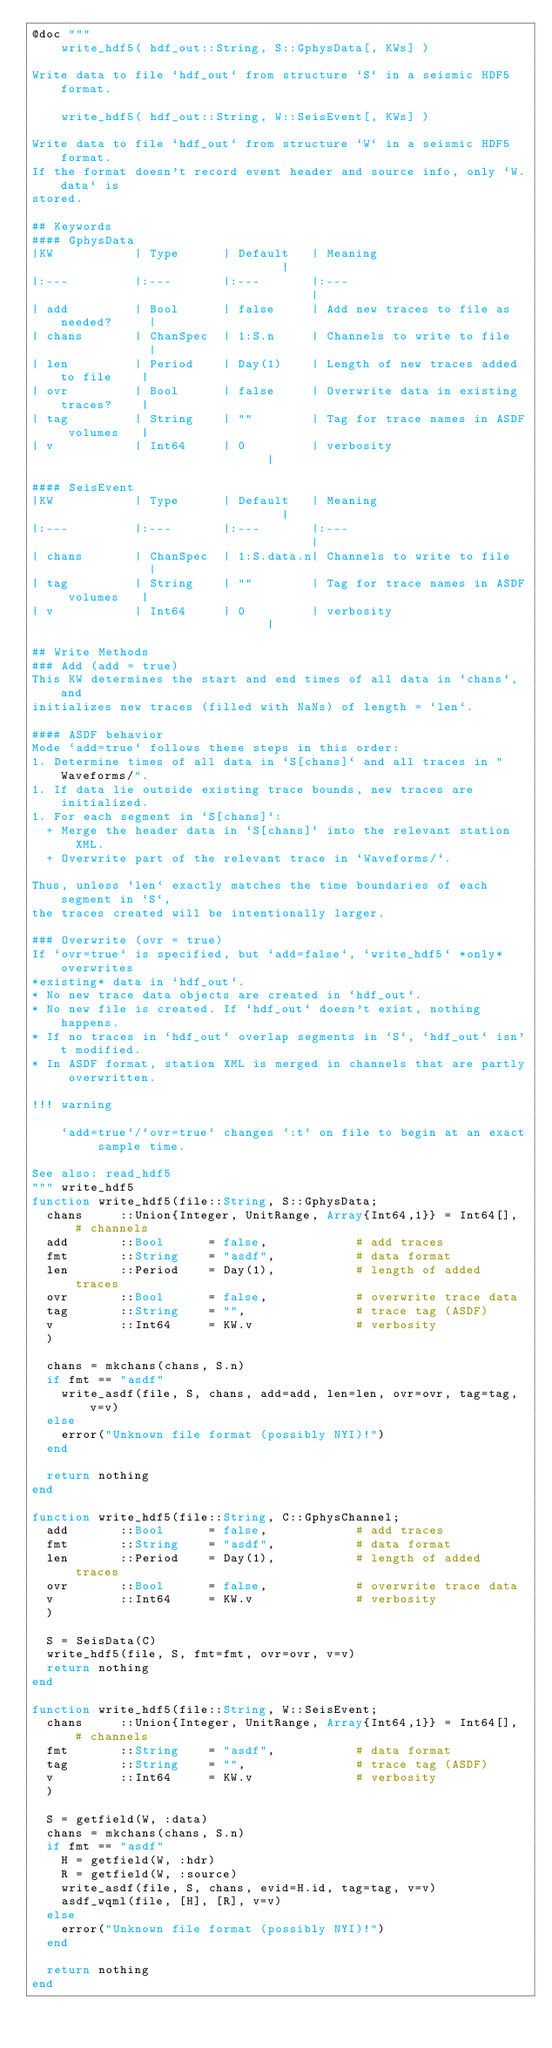Convert code to text. <code><loc_0><loc_0><loc_500><loc_500><_Julia_>@doc """
    write_hdf5( hdf_out::String, S::GphysData[, KWs] )

Write data to file `hdf_out` from structure `S` in a seismic HDF5 format.

    write_hdf5( hdf_out::String, W::SeisEvent[, KWs] )

Write data to file `hdf_out` from structure `W` in a seismic HDF5 format.
If the format doesn't record event header and source info, only `W.data` is
stored.

## Keywords
#### GphysData
|KW           | Type      | Default   | Meaning                               |
|:---         |:---       |:---       |:---                                   |
| add         | Bool      | false     | Add new traces to file as needed?     |
| chans       | ChanSpec  | 1:S.n     | Channels to write to file             |
| len         | Period    | Day(1)    | Length of new traces added to file    |
| ovr         | Bool      | false     | Overwrite data in existing traces?    |
| tag         | String    | ""        | Tag for trace names in ASDF volumes   |
| v           | Int64     | 0         | verbosity                             |

#### SeisEvent
|KW           | Type      | Default   | Meaning                               |
|:---         |:---       |:---       |:---                                   |
| chans       | ChanSpec  | 1:S.data.n| Channels to write to file             |
| tag         | String    | ""        | Tag for trace names in ASDF volumes   |
| v           | Int64     | 0         | verbosity                             |

## Write Methods
### Add (add = true)
This KW determines the start and end times of all data in `chans`, and
initializes new traces (filled with NaNs) of length = `len`.

#### ASDF behavior
Mode `add=true` follows these steps in this order:
1. Determine times of all data in `S[chans]` and all traces in "Waveforms/".
1. If data lie outside existing trace bounds, new traces are initialized.
1. For each segment in `S[chans]`:
  + Merge the header data in `S[chans]` into the relevant station XML.
  + Overwrite part of the relevant trace in `Waveforms/`.

Thus, unless `len` exactly matches the time boundaries of each segment in `S`,
the traces created will be intentionally larger.

### Overwrite (ovr = true)
If `ovr=true` is specified, but `add=false`, `write_hdf5` *only* overwrites
*existing* data in `hdf_out`.
* No new trace data objects are created in `hdf_out`.
* No new file is created. If `hdf_out` doesn't exist, nothing happens.
* If no traces in `hdf_out` overlap segments in `S`, `hdf_out` isn't modified.
* In ASDF format, station XML is merged in channels that are partly overwritten.

!!! warning

    `add=true`/`ovr=true` changes `:t` on file to begin at an exact sample time.

See also: read_hdf5
""" write_hdf5
function write_hdf5(file::String, S::GphysData;
  chans     ::Union{Integer, UnitRange, Array{Int64,1}} = Int64[], # channels
  add       ::Bool      = false,            # add traces
  fmt       ::String    = "asdf",           # data format
  len       ::Period    = Day(1),           # length of added traces
  ovr       ::Bool      = false,            # overwrite trace data
  tag       ::String    = "",               # trace tag (ASDF)
  v         ::Int64     = KW.v              # verbosity
  )

  chans = mkchans(chans, S.n)
  if fmt == "asdf"
    write_asdf(file, S, chans, add=add, len=len, ovr=ovr, tag=tag, v=v)
  else
    error("Unknown file format (possibly NYI)!")
  end

  return nothing
end

function write_hdf5(file::String, C::GphysChannel;
  add       ::Bool      = false,            # add traces
  fmt       ::String    = "asdf",           # data format
  len       ::Period    = Day(1),           # length of added traces
  ovr       ::Bool      = false,            # overwrite trace data
  v         ::Int64     = KW.v              # verbosity
  )

  S = SeisData(C)
  write_hdf5(file, S, fmt=fmt, ovr=ovr, v=v)
  return nothing
end

function write_hdf5(file::String, W::SeisEvent;
  chans     ::Union{Integer, UnitRange, Array{Int64,1}} = Int64[], # channels
  fmt       ::String    = "asdf",           # data format
  tag       ::String    = "",               # trace tag (ASDF)
  v         ::Int64     = KW.v              # verbosity
  )

  S = getfield(W, :data)
  chans = mkchans(chans, S.n)
  if fmt == "asdf"
    H = getfield(W, :hdr)
    R = getfield(W, :source)
    write_asdf(file, S, chans, evid=H.id, tag=tag, v=v)
    asdf_wqml(file, [H], [R], v=v)
  else
    error("Unknown file format (possibly NYI)!")
  end

  return nothing
end
</code> 